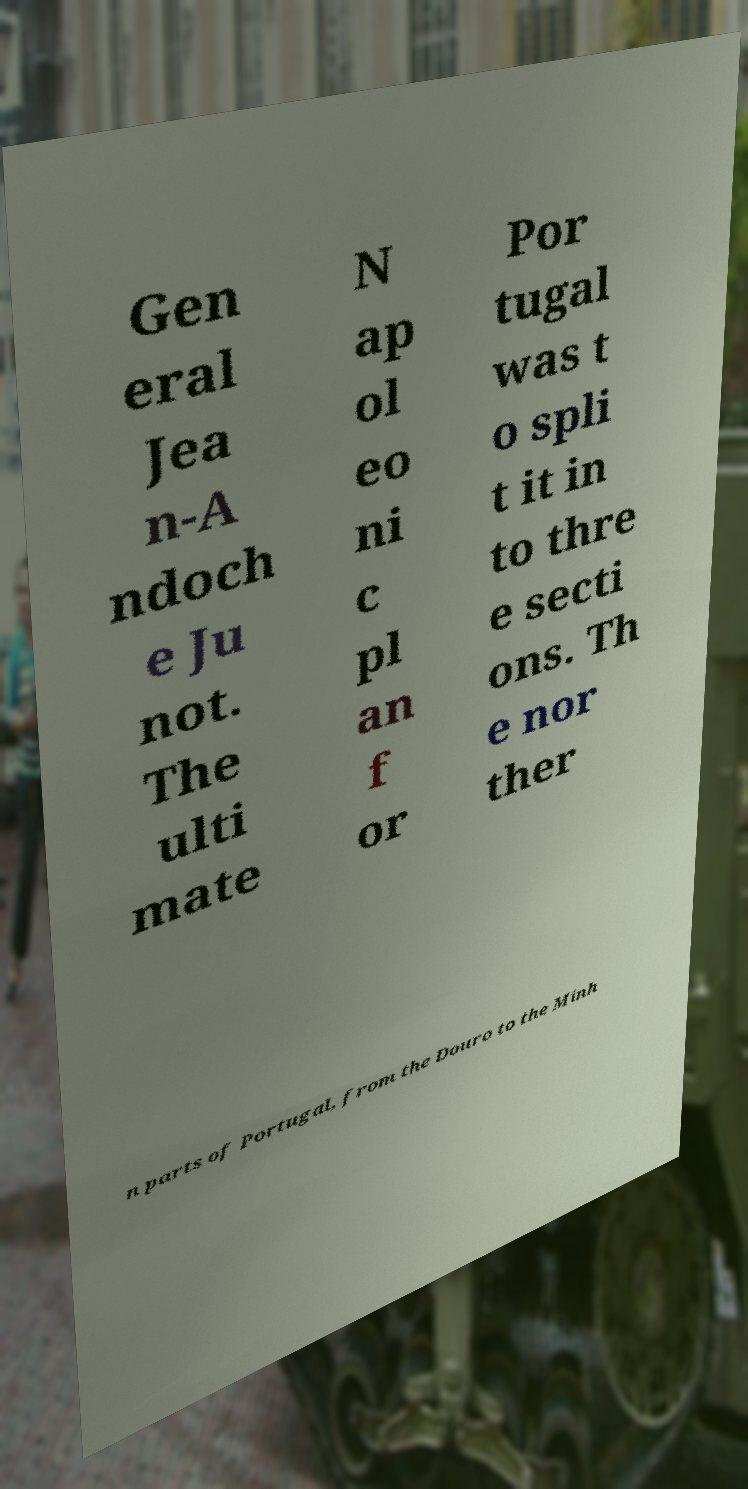For documentation purposes, I need the text within this image transcribed. Could you provide that? Gen eral Jea n-A ndoch e Ju not. The ulti mate N ap ol eo ni c pl an f or Por tugal was t o spli t it in to thre e secti ons. Th e nor ther n parts of Portugal, from the Douro to the Minh 